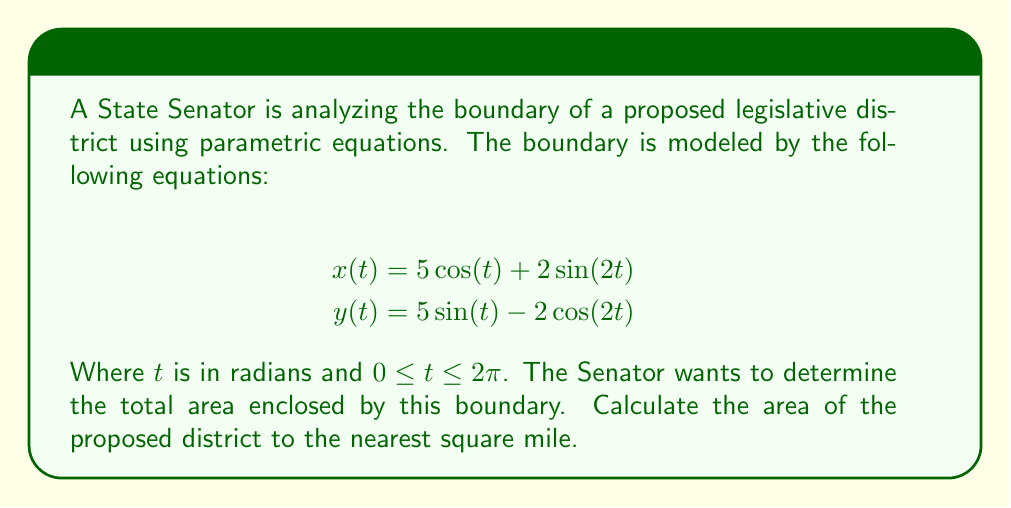Give your solution to this math problem. To find the area enclosed by a parametric curve, we can use Green's theorem, which relates a line integral around a simple closed curve to a double integral over the region it encloses. The formula for the area is:

$$A = \frac{1}{2} \int_0^{2\pi} [x(t)\frac{dy}{dt} - y(t)\frac{dx}{dt}] dt$$

Let's follow these steps:

1) First, we need to find $\frac{dx}{dt}$ and $\frac{dy}{dt}$:

   $$\frac{dx}{dt} = -5\sin(t) + 4\cos(2t)$$
   $$\frac{dy}{dt} = 5\cos(t) + 4\sin(2t)$$

2) Now, let's substitute these into the area formula:

   $$A = \frac{1}{2} \int_0^{2\pi} [(5\cos(t) + 2\sin(2t))(5\cos(t) + 4\sin(2t)) - (5\sin(t) - 2\cos(2t))(-5\sin(t) + 4\cos(2t))] dt$$

3) Expand the integrand:

   $$A = \frac{1}{2} \int_0^{2\pi} [25\cos^2(t) + 20\cos(t)\sin(2t) + 10\sin(2t)\cos(t) + 8\sin^2(2t) + 25\sin^2(t) - 20\sin(t)\cos(2t) - 10\cos(2t)\sin(t) + 8\cos^2(2t)] dt$$

4) Simplify using trigonometric identities:

   $$A = \frac{1}{2} \int_0^{2\pi} [25 + 30\sin(2t)\cos(t) - 30\sin(t)\cos(2t) + 8] dt$$
   $$A = \frac{1}{2} \int_0^{2\pi} [33 + 30\sin(2t)\cos(t) - 30\sin(t)\cos(2t)] dt$$

5) The integral of a constant over a full period is just the constant times $2\pi$. The other terms integrate to zero over a full period. So:

   $$A = \frac{1}{2} [33 \cdot 2\pi] = 33\pi$$

6) Therefore, the area is $33\pi$ square miles. Rounding to the nearest square mile:

   $$33\pi \approx 103.67 \approx 104$$ square miles
Answer: 104 square miles 